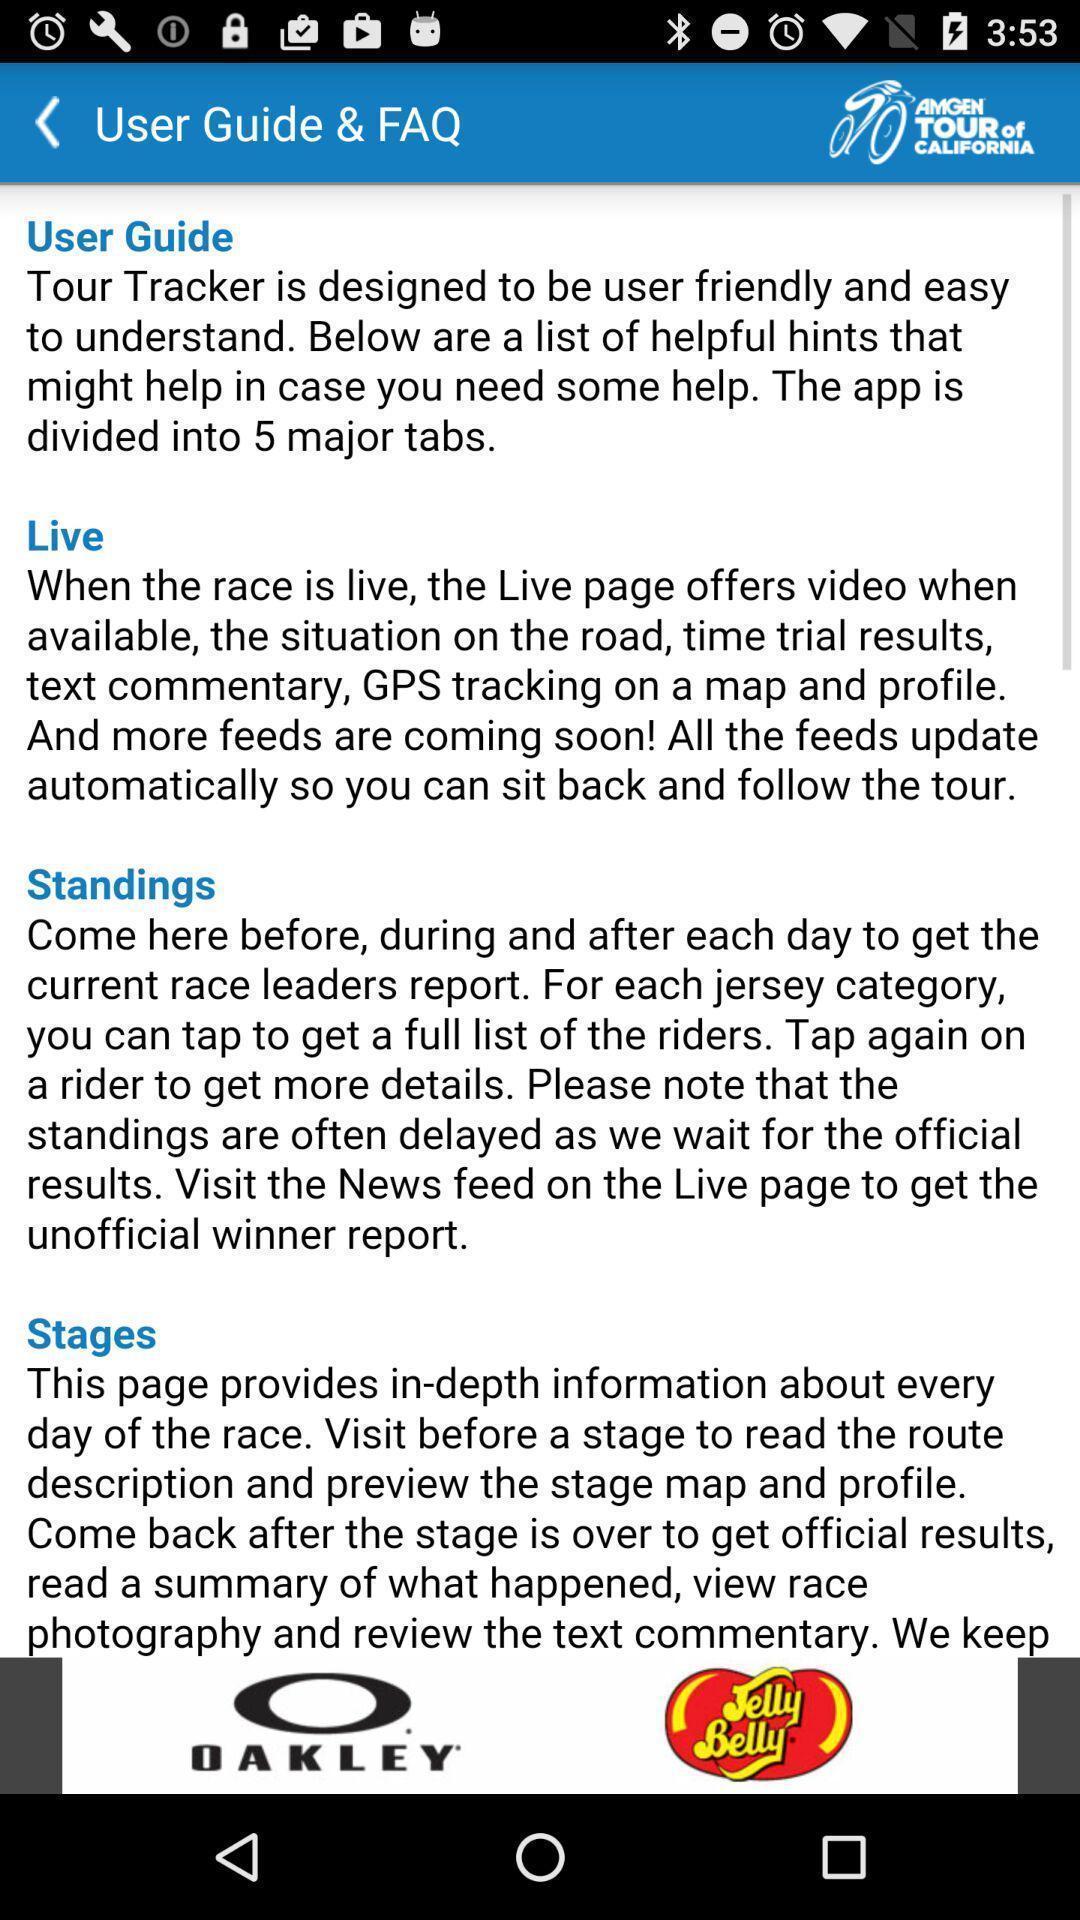Summarize the main components in this picture. Screen showing user guide faq. 